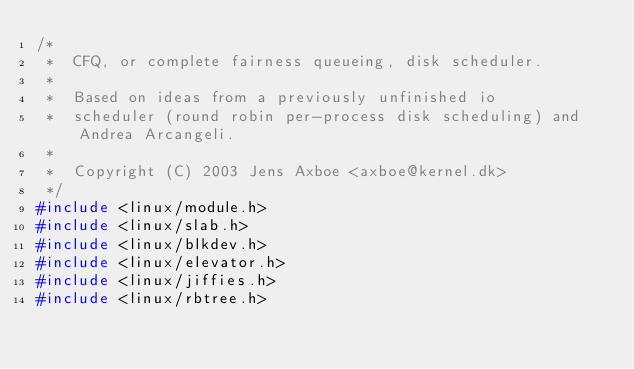Convert code to text. <code><loc_0><loc_0><loc_500><loc_500><_C_>/*
 *  CFQ, or complete fairness queueing, disk scheduler.
 *
 *  Based on ideas from a previously unfinished io
 *  scheduler (round robin per-process disk scheduling) and Andrea Arcangeli.
 *
 *  Copyright (C) 2003 Jens Axboe <axboe@kernel.dk>
 */
#include <linux/module.h>
#include <linux/slab.h>
#include <linux/blkdev.h>
#include <linux/elevator.h>
#include <linux/jiffies.h>
#include <linux/rbtree.h></code> 